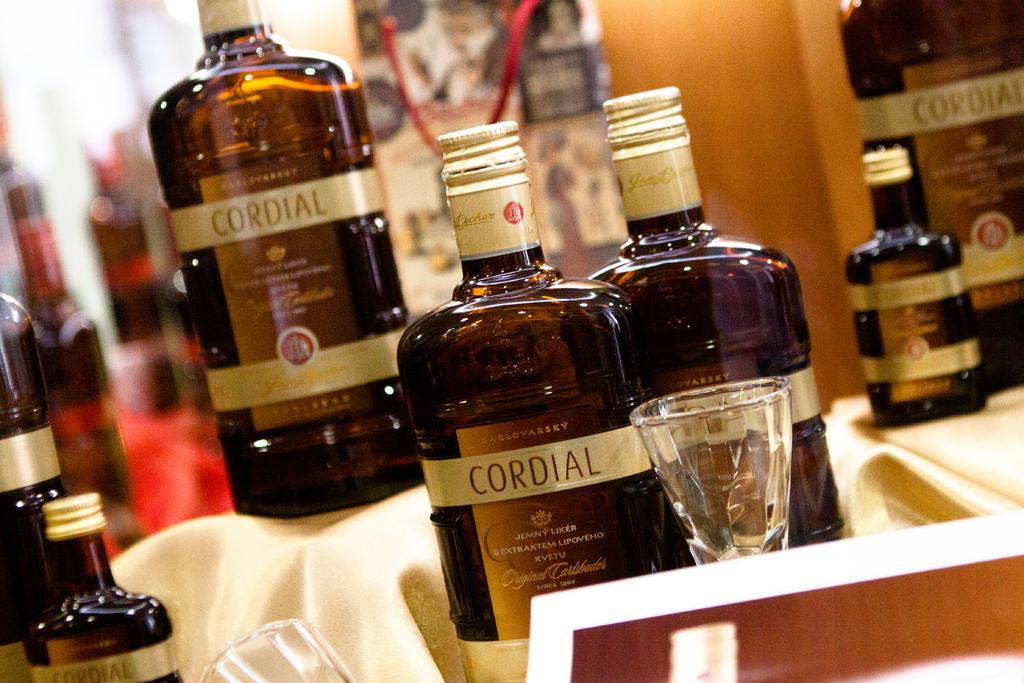Provide a one-sentence caption for the provided image. Here we have a display for several bottles of Cordial and some tasting glasses. 